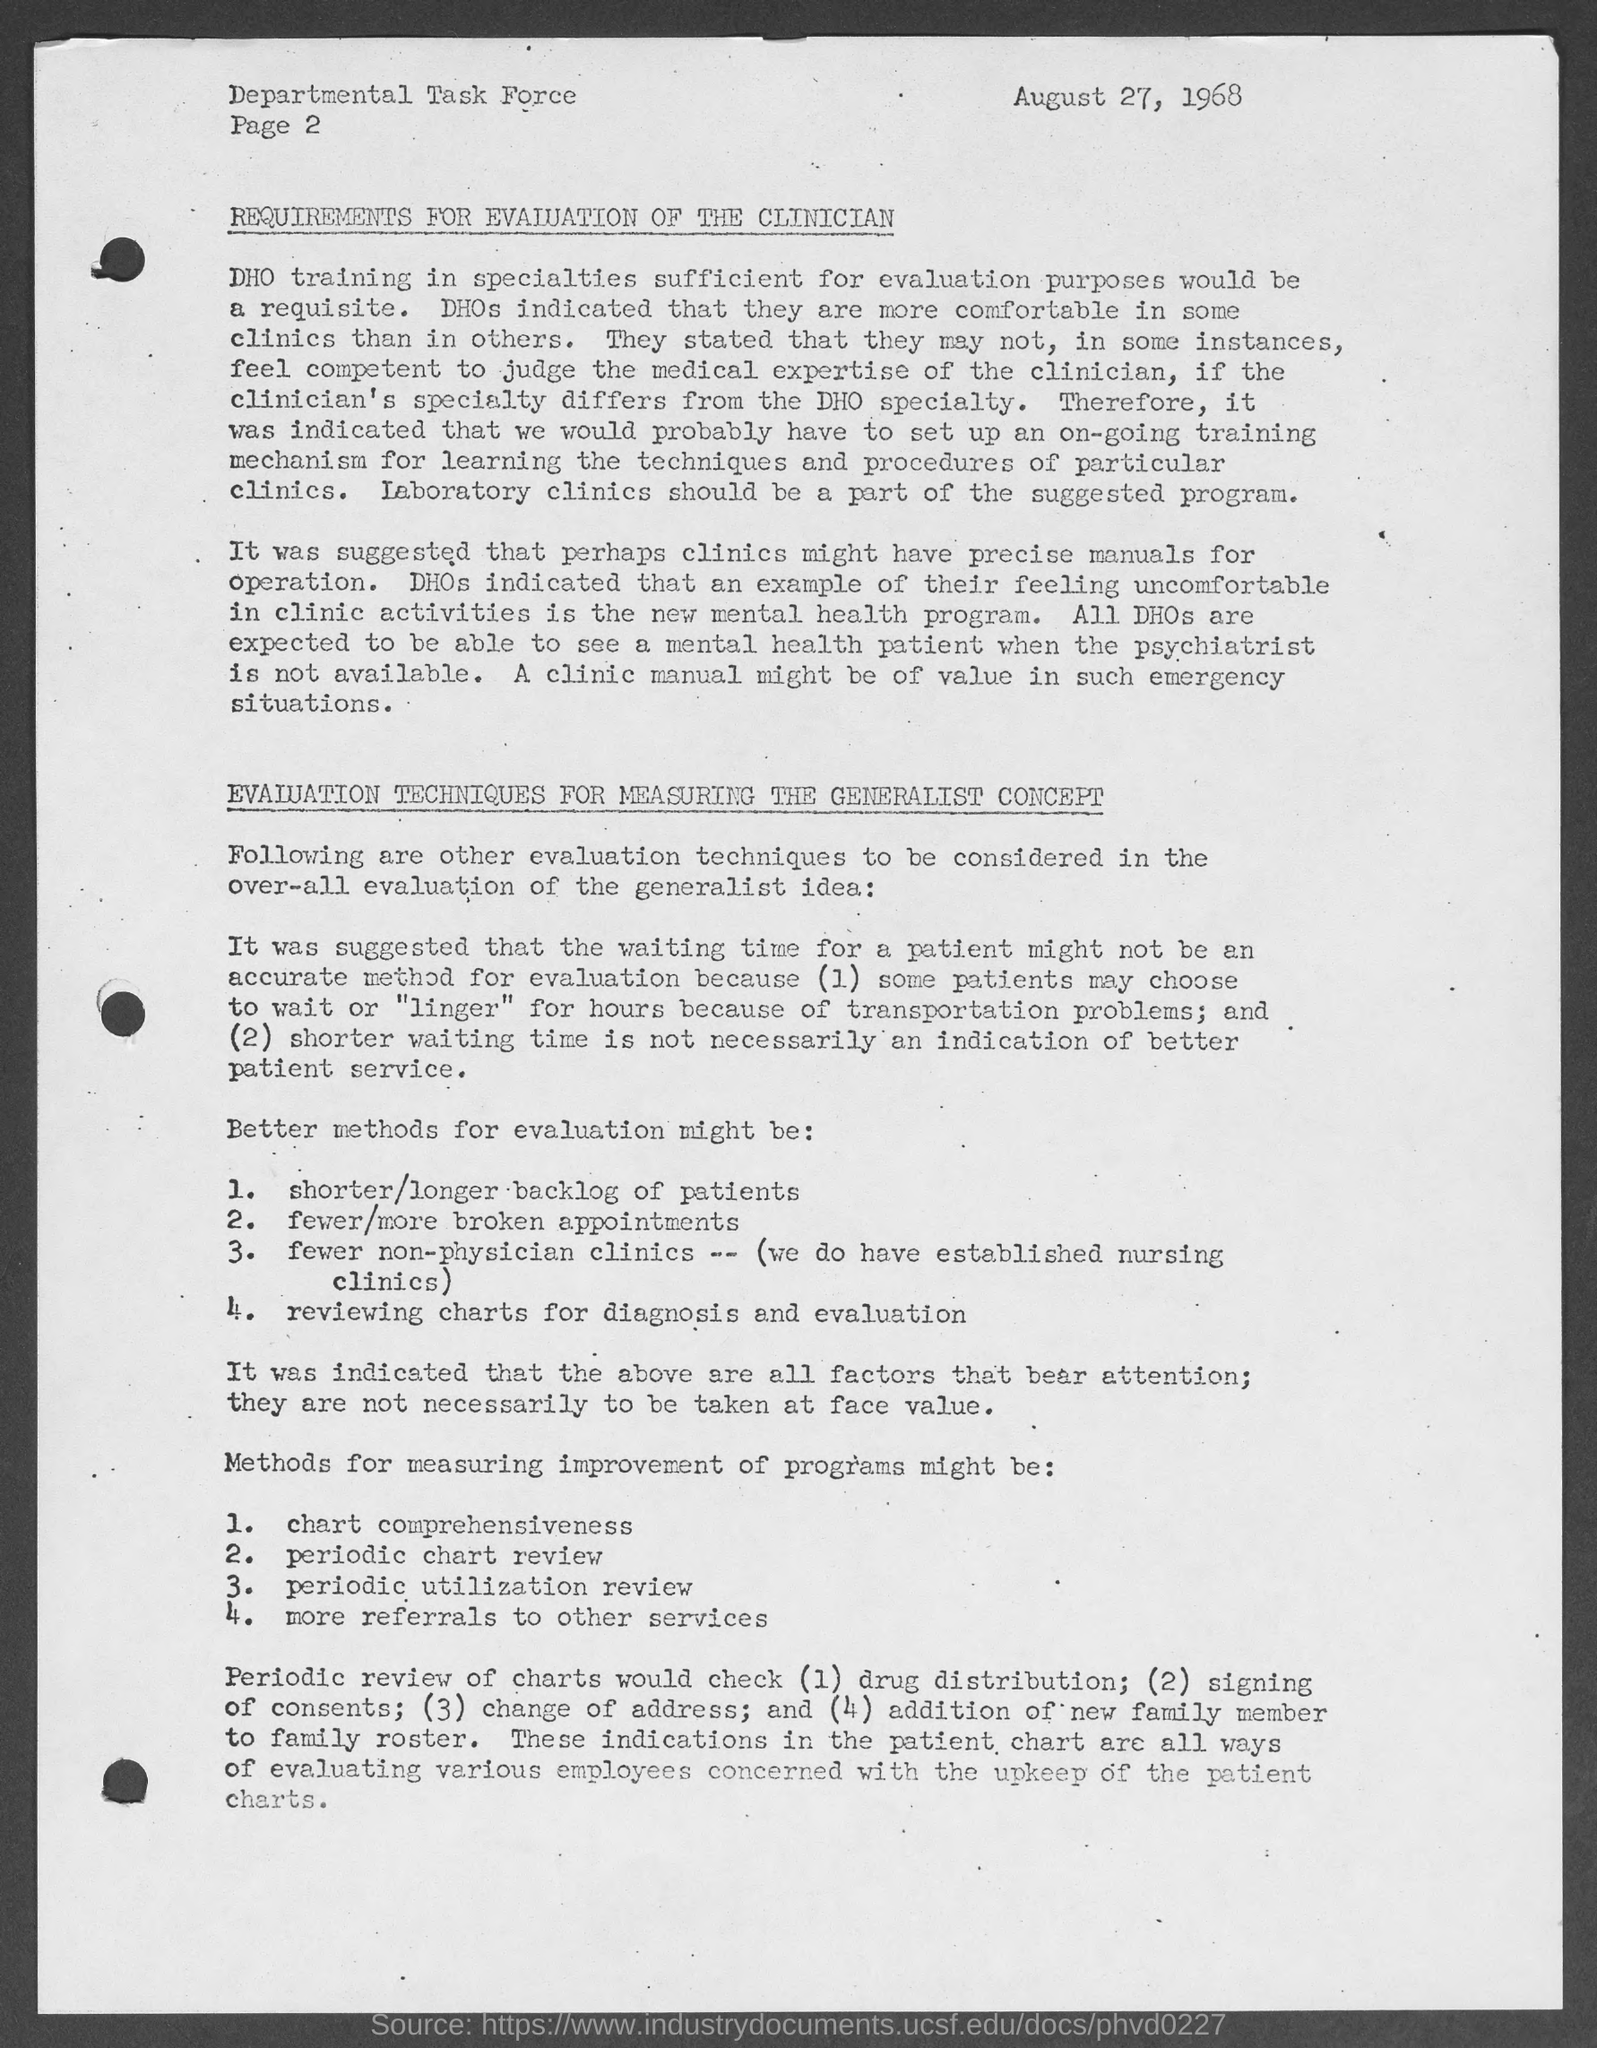Identify some key points in this picture. The second page of the document has been located. The date mentioned in the document is August 27, 1968. 